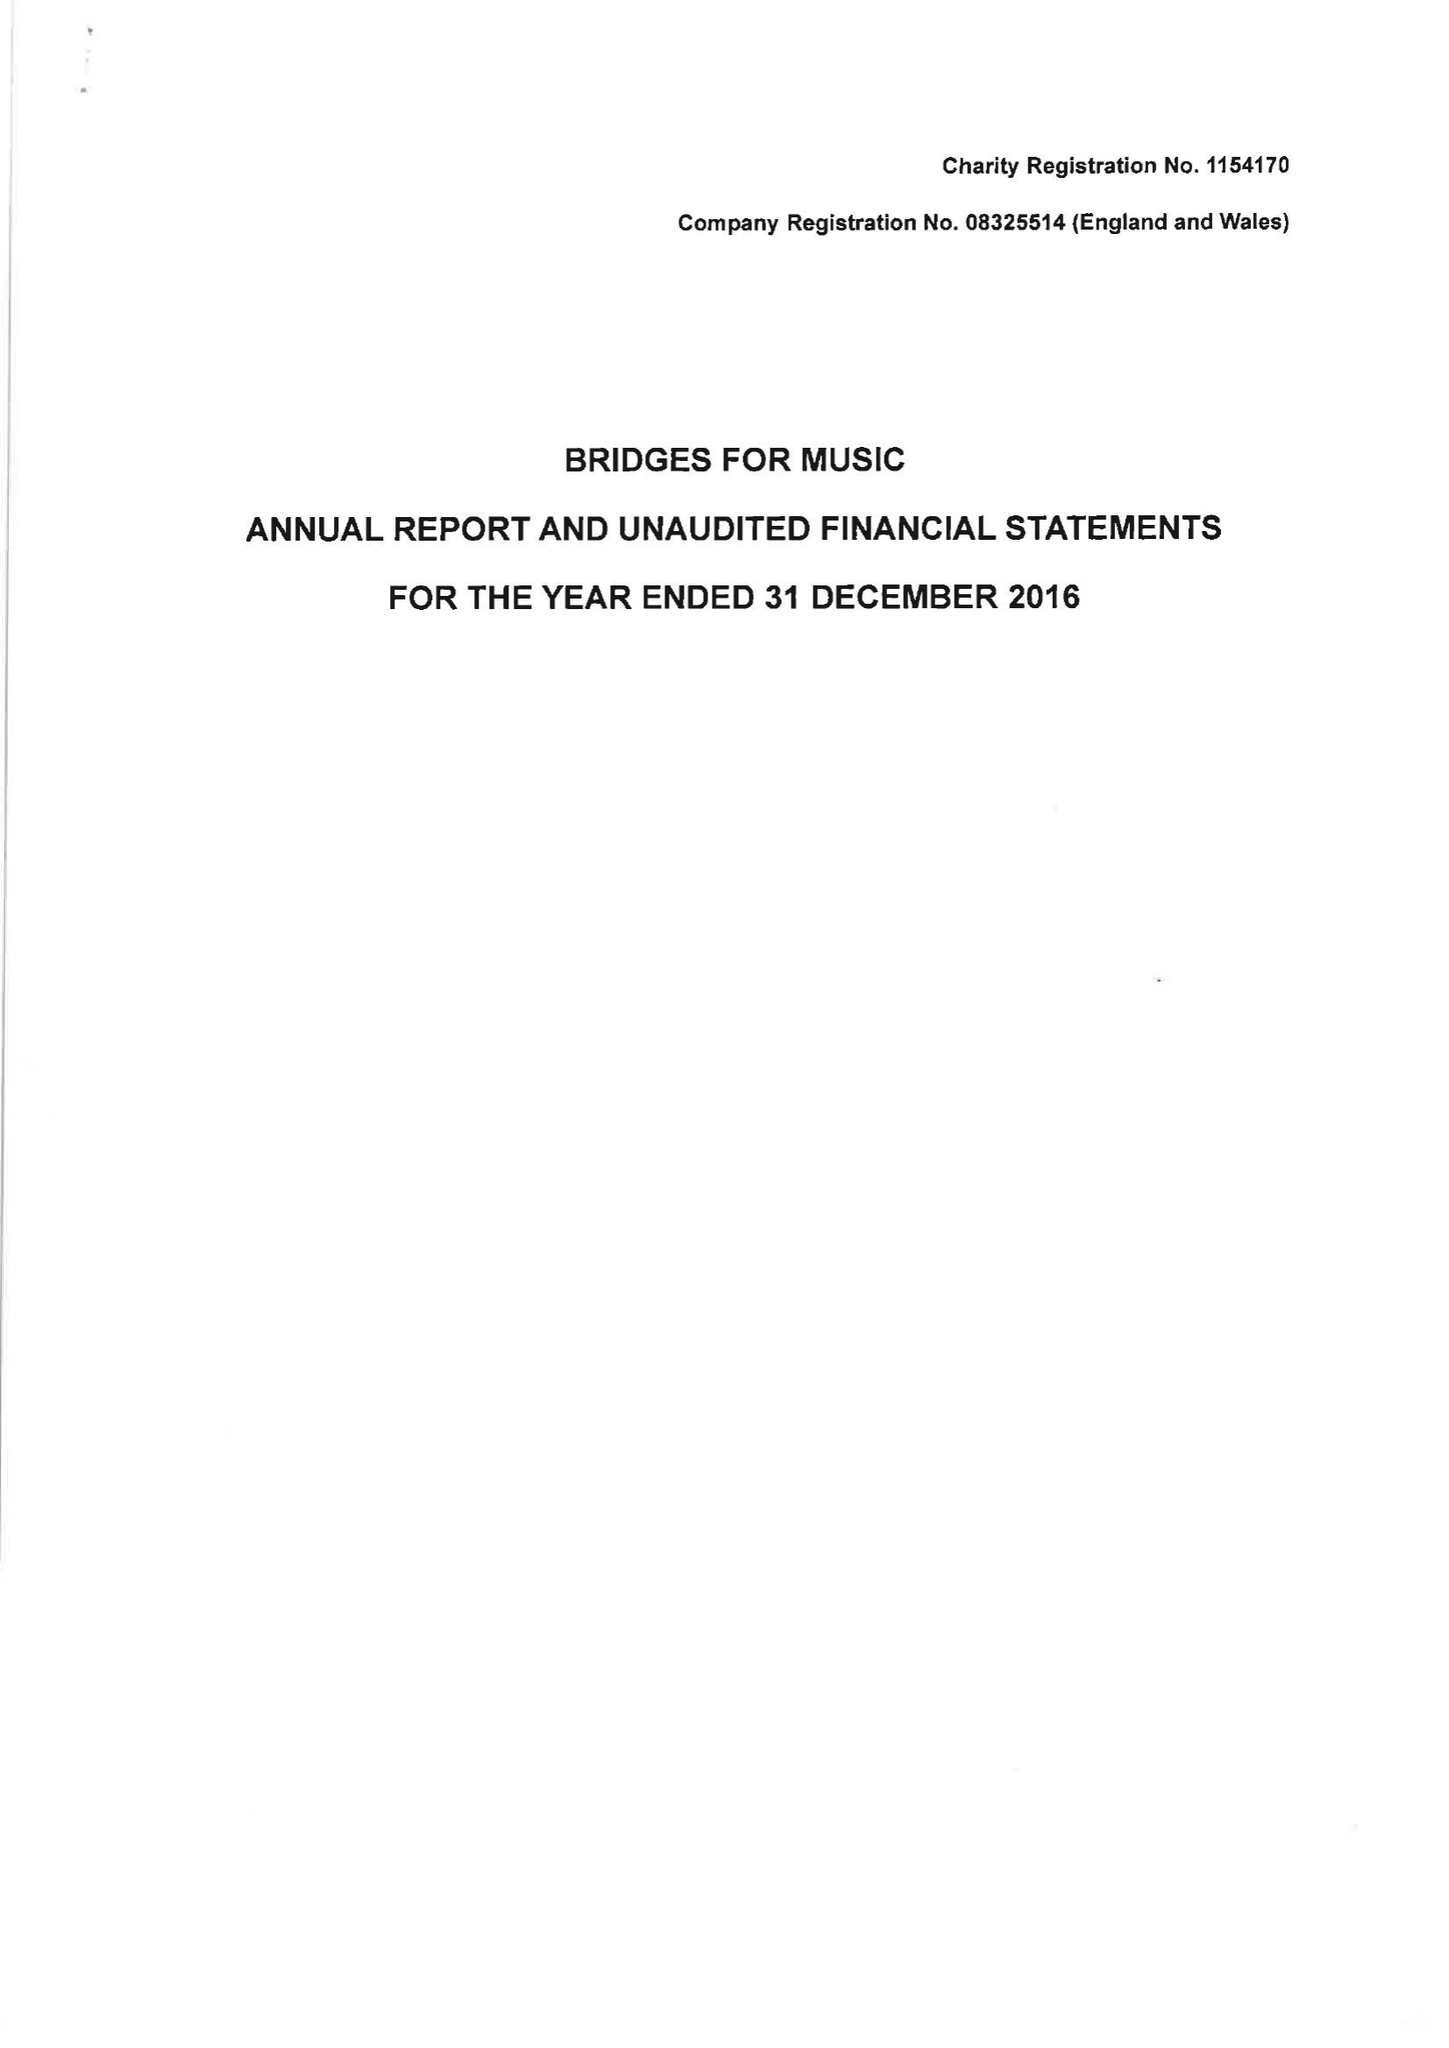What is the value for the address__postcode?
Answer the question using a single word or phrase. WC2B 4AS 